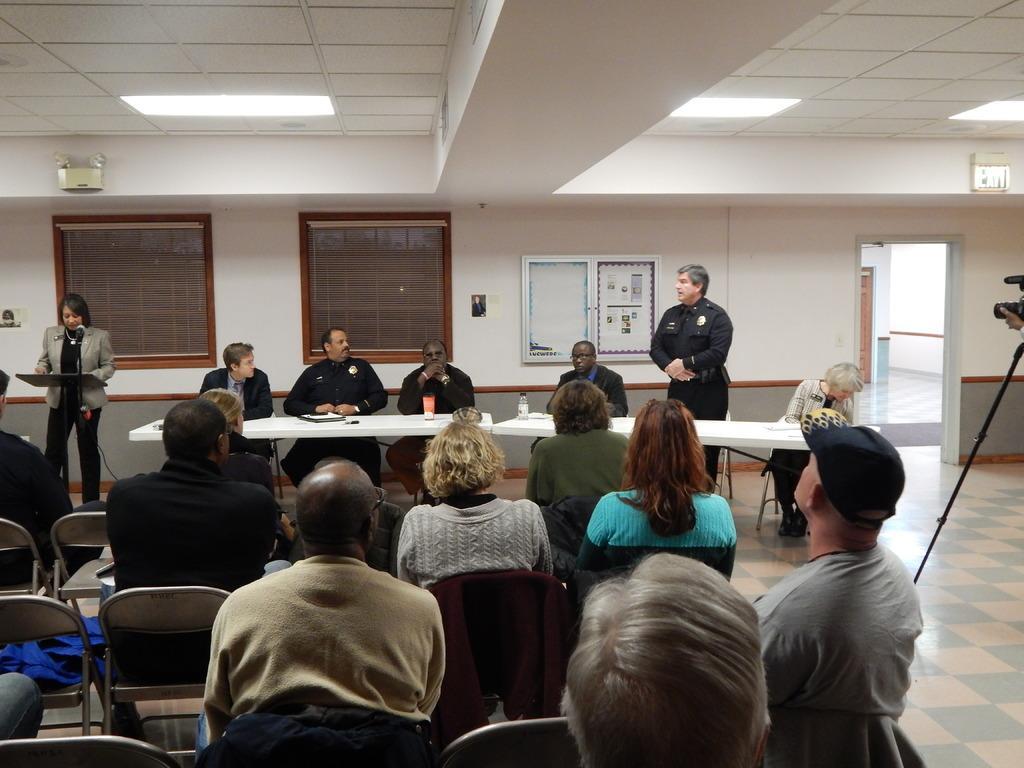In one or two sentences, can you explain what this image depicts? In the center of the image we can see some persons are sitting on the chairs, in-front of them we can see the tables. On the tables we can see the bottle, glass, paper and some objects. At the bottom of the image we can see a group of people are sitting on the chairs. On the left side of the image we can see a lady is standing in-front of stand and mic. In the background of the image we can see the boards, wall, windows, door. At the top of the image we can see the roof and lights. On the right side of the image we can see a person is holding a camera with stand and floor. 